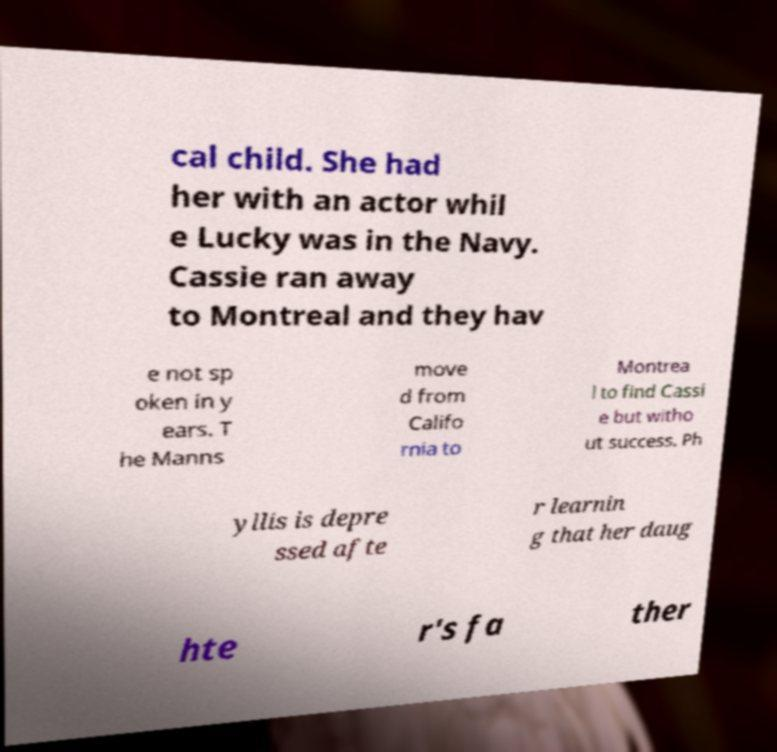What messages or text are displayed in this image? I need them in a readable, typed format. cal child. She had her with an actor whil e Lucky was in the Navy. Cassie ran away to Montreal and they hav e not sp oken in y ears. T he Manns move d from Califo rnia to Montrea l to find Cassi e but witho ut success. Ph yllis is depre ssed afte r learnin g that her daug hte r's fa ther 